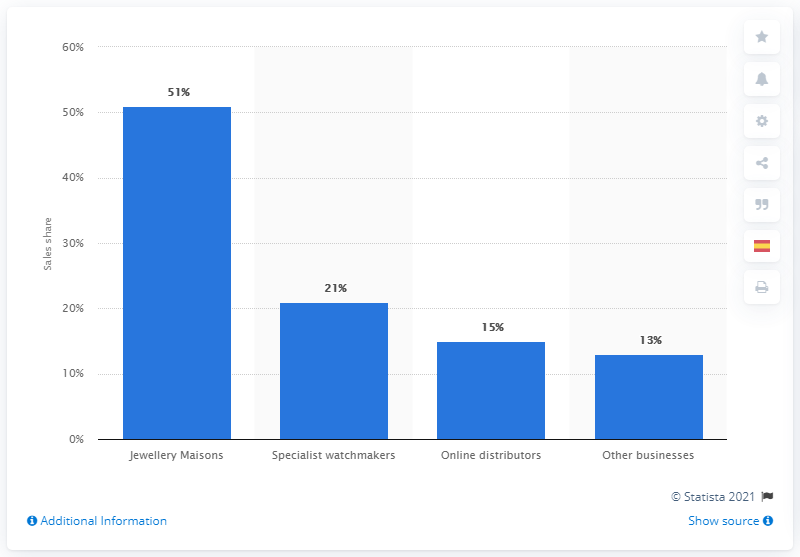Give some essential details in this illustration. The sales share of the Richemont Group's specialist watchmakers segment worldwide in FY2020 was 21%. 